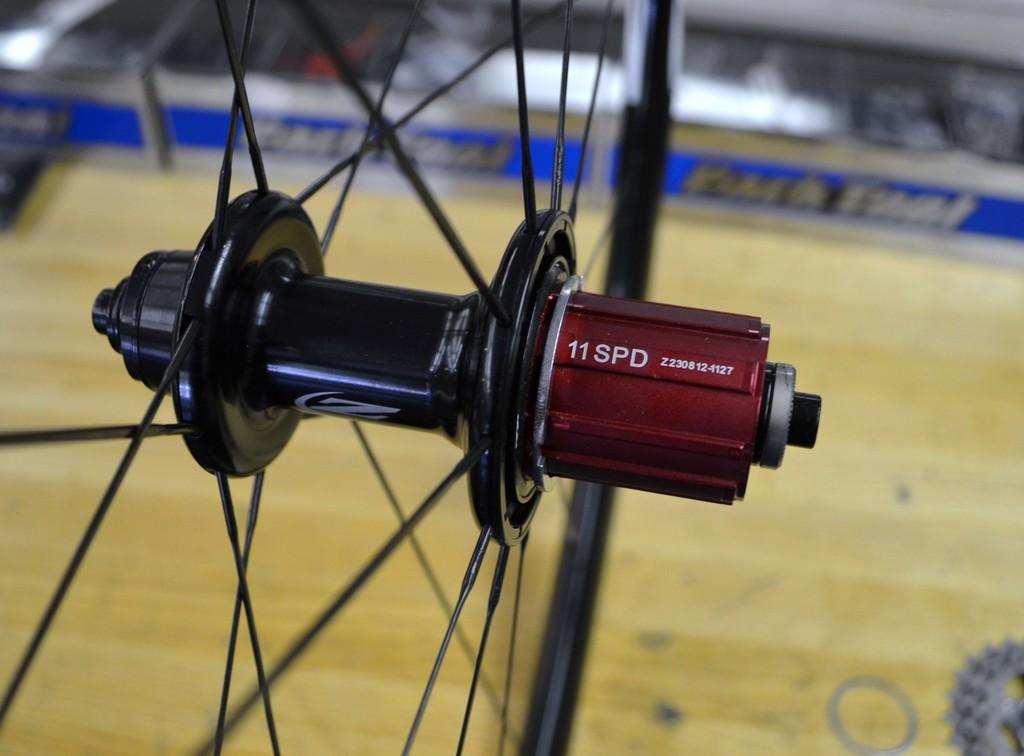What is the main subject of the image? The main subject of the image is a hub flange. What are the spokes in the image connected to? The spokes in the image are connected to the hub flange. What is the purpose of the quick release cap in the image? The quick release cap in the image is used to secure or release the wheel. What is the skewer used for in the image? The skewer in the image is used to hold the wheel together. What can be inferred about the focus of the image? The background of the image is blurred, indicating that the focus is on the main subject. What type of surface is visible in the image? There is a wooden surface visible in the image. What other objects can be seen in the image? There are some objects in the image, but their specific details are not mentioned in the provided facts. How many seeds are visible on the umbrella in the image? There is no umbrella or seeds present in the image. What type of attention is the image trying to draw from the viewer? The image is not trying to draw any specific type of attention from the viewer; it simply presents the main subject and its components. 